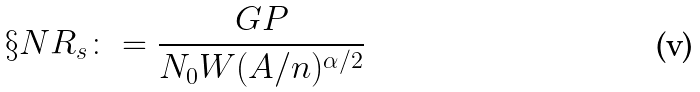Convert formula to latex. <formula><loc_0><loc_0><loc_500><loc_500>\S N R _ { s } \colon = \frac { G P } { N _ { 0 } W ( A / n ) ^ { \alpha / 2 } }</formula> 